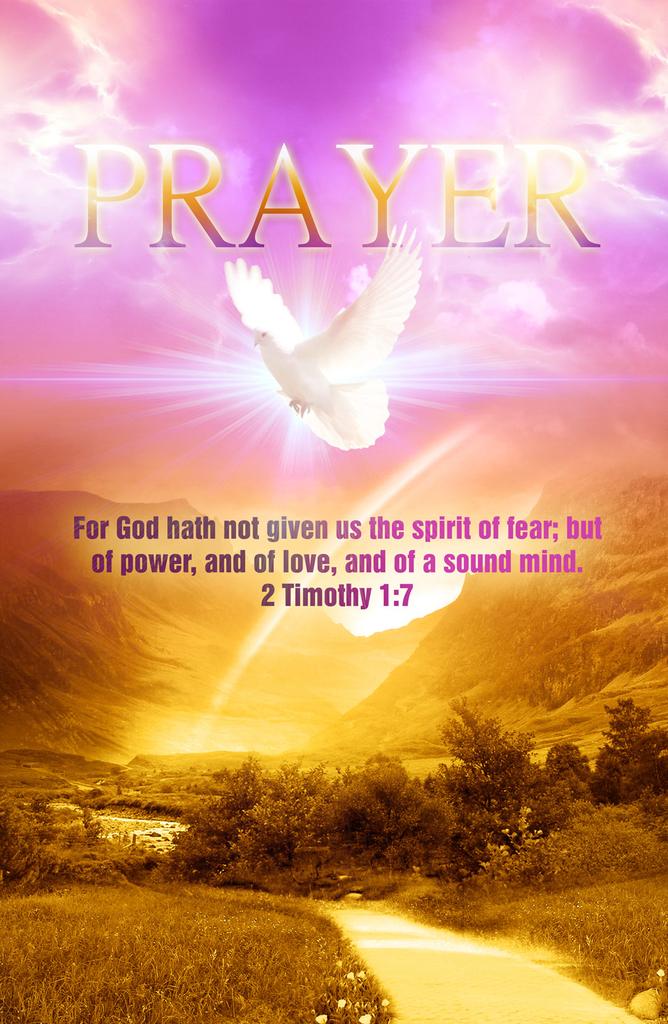What verse of the bible is this quotation taken from?
Your response must be concise. 2 timothy 1:7. What is the title of the ad?
Make the answer very short. Prayer. 